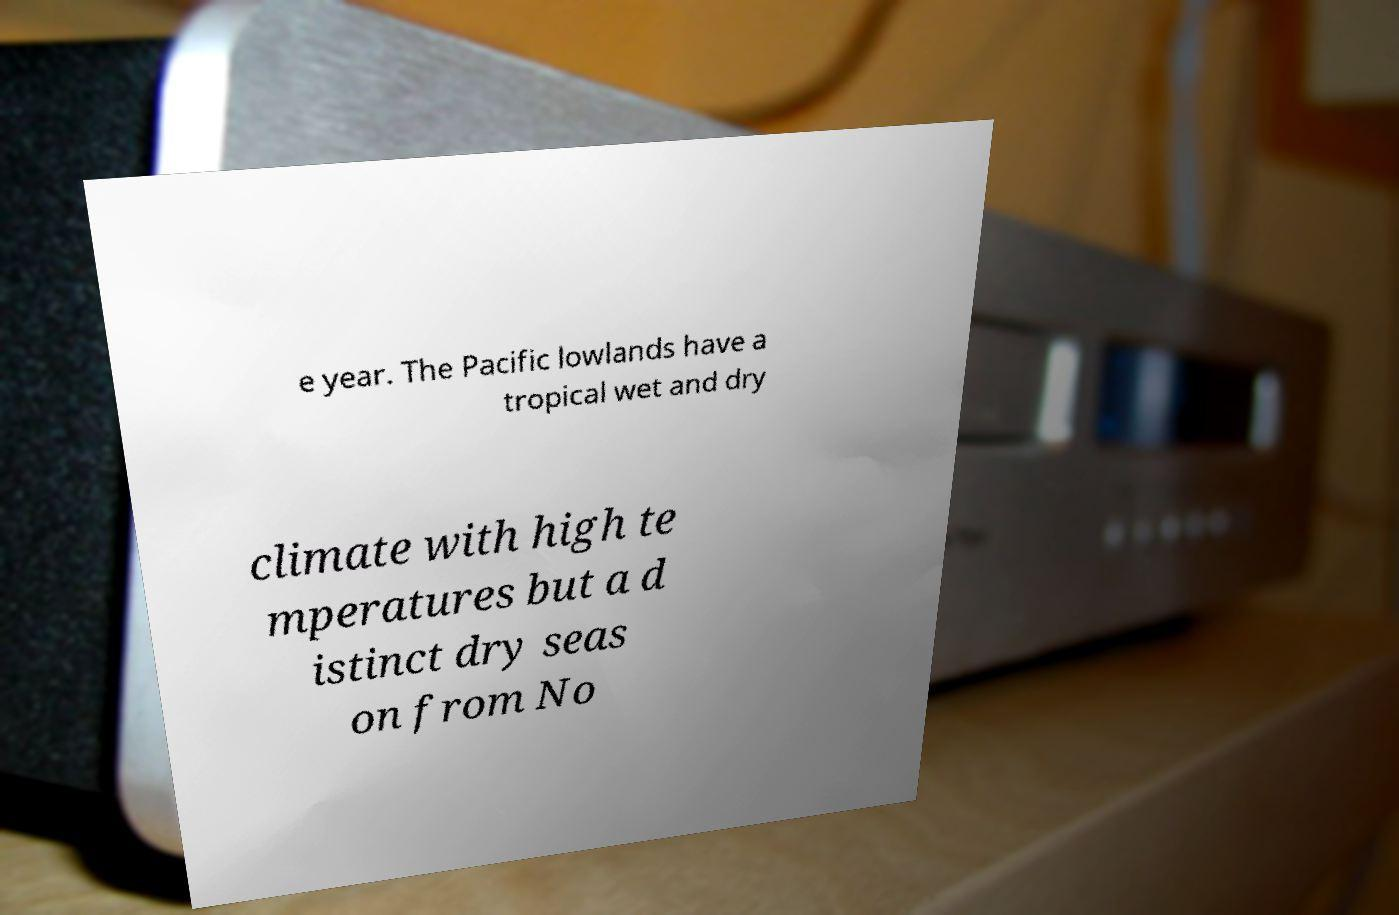Please read and relay the text visible in this image. What does it say? e year. The Pacific lowlands have a tropical wet and dry climate with high te mperatures but a d istinct dry seas on from No 